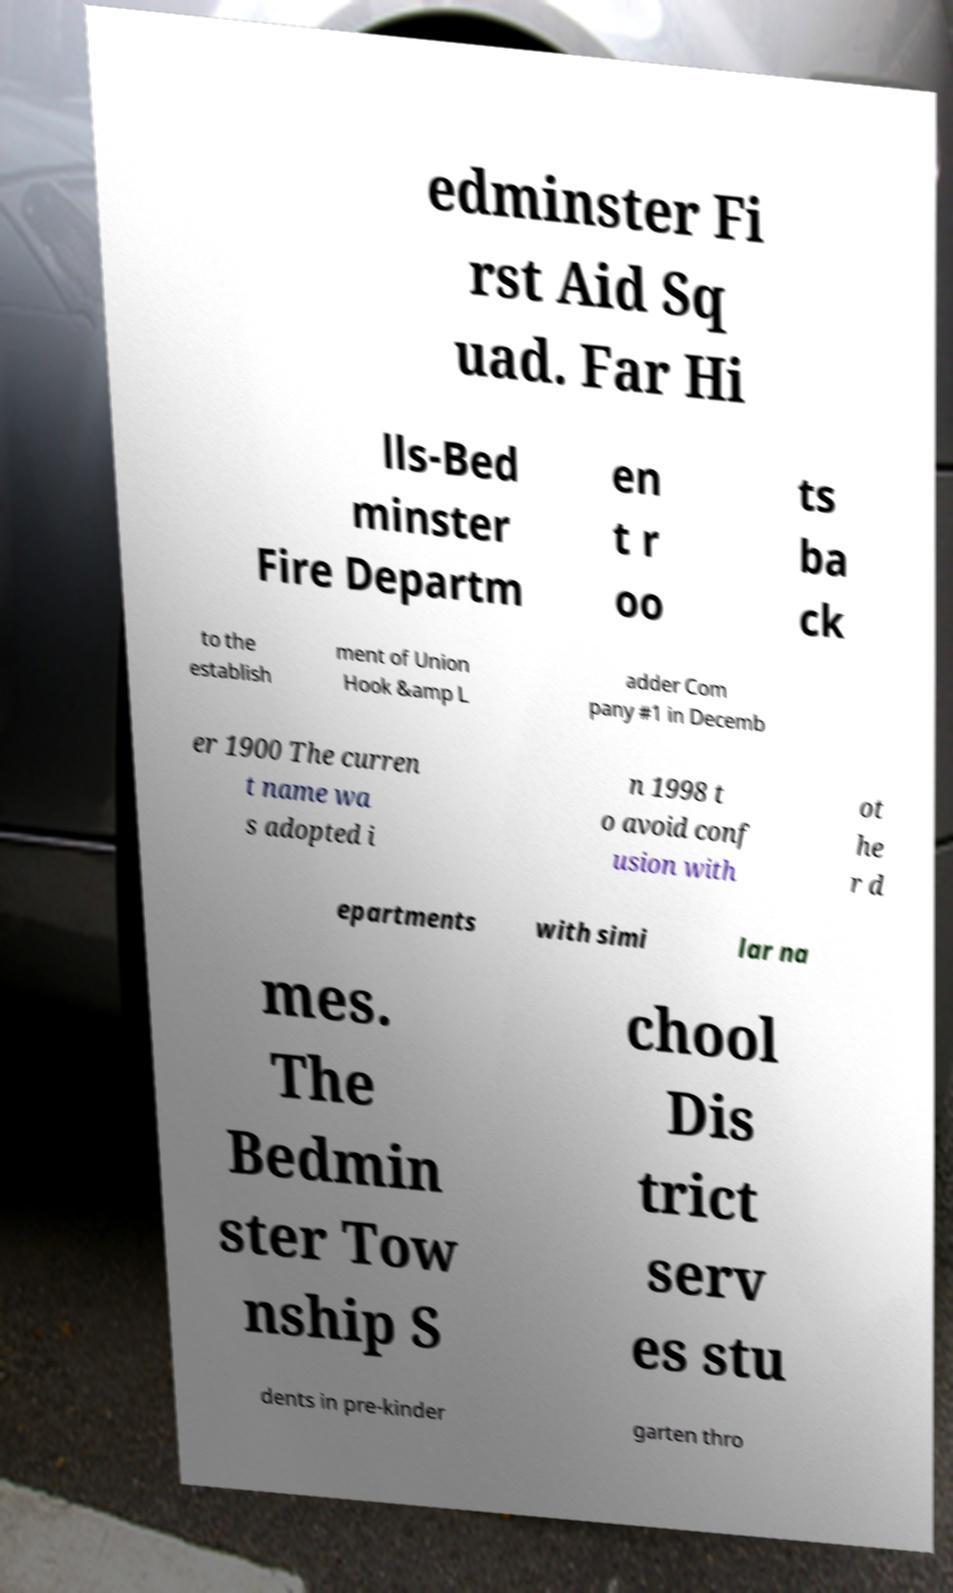Could you assist in decoding the text presented in this image and type it out clearly? edminster Fi rst Aid Sq uad. Far Hi lls-Bed minster Fire Departm en t r oo ts ba ck to the establish ment of Union Hook &amp L adder Com pany #1 in Decemb er 1900 The curren t name wa s adopted i n 1998 t o avoid conf usion with ot he r d epartments with simi lar na mes. The Bedmin ster Tow nship S chool Dis trict serv es stu dents in pre-kinder garten thro 